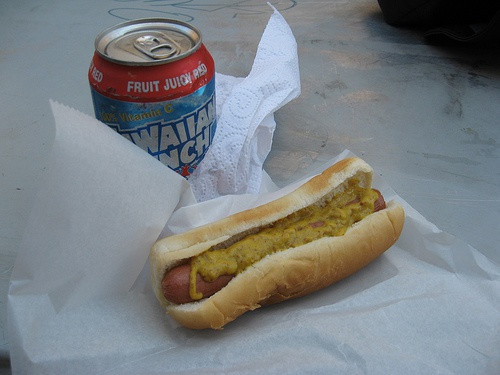Describe the objects in this image and their specific colors. I can see a hot dog in gray, olive, tan, and darkgray tones in this image. 